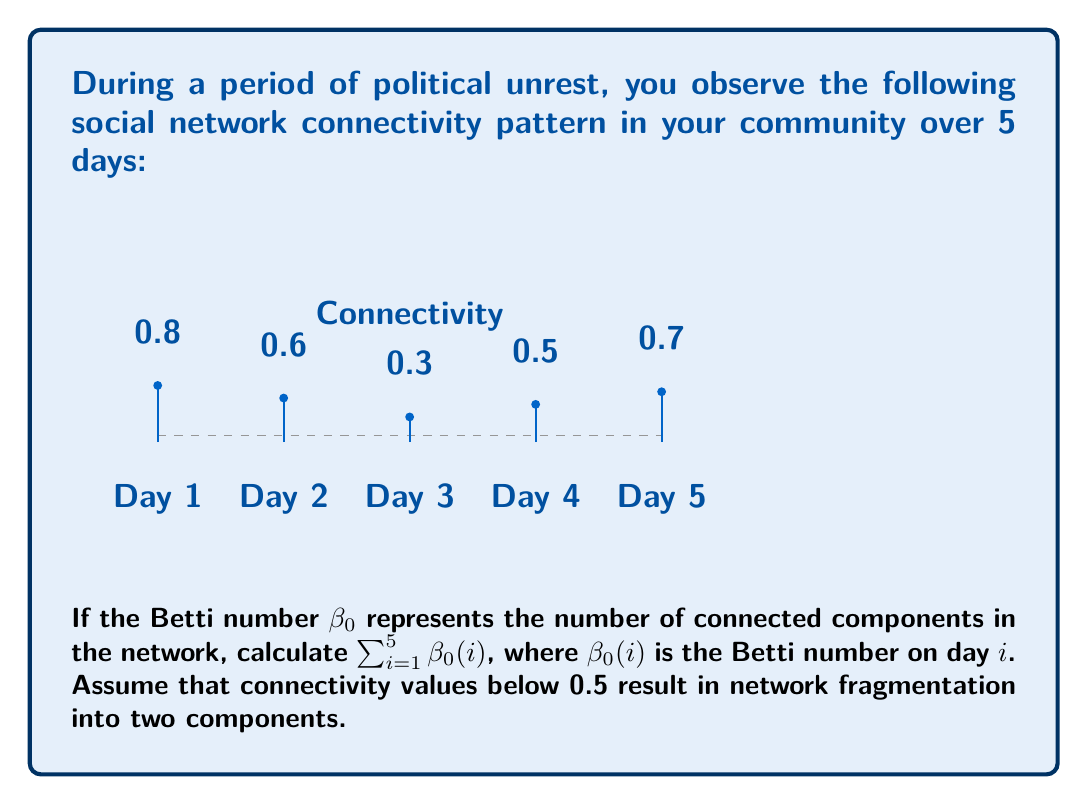Teach me how to tackle this problem. To solve this problem, we need to analyze the connectivity values for each day and determine the number of connected components ($\beta_0$) based on the given threshold:

1. Day 1: Connectivity = 0.8
   $0.8 > 0.5$, so the network is fully connected.
   $\beta_0(1) = 1$

2. Day 2: Connectivity = 0.6
   $0.6 > 0.5$, so the network is fully connected.
   $\beta_0(2) = 1$

3. Day 3: Connectivity = 0.3
   $0.3 < 0.5$, so the network is fragmented into two components.
   $\beta_0(3) = 2$

4. Day 4: Connectivity = 0.5
   $0.5 = 0.5$, we assume this results in a fully connected network.
   $\beta_0(4) = 1$

5. Day 5: Connectivity = 0.7
   $0.7 > 0.5$, so the network is fully connected.
   $\beta_0(5) = 1$

Now, we can calculate the sum of Betti numbers:

$$\sum_{i=1}^5 \beta_0(i) = \beta_0(1) + \beta_0(2) + \beta_0(3) + \beta_0(4) + \beta_0(5)$$
$$= 1 + 1 + 2 + 1 + 1 = 6$$
Answer: 6 